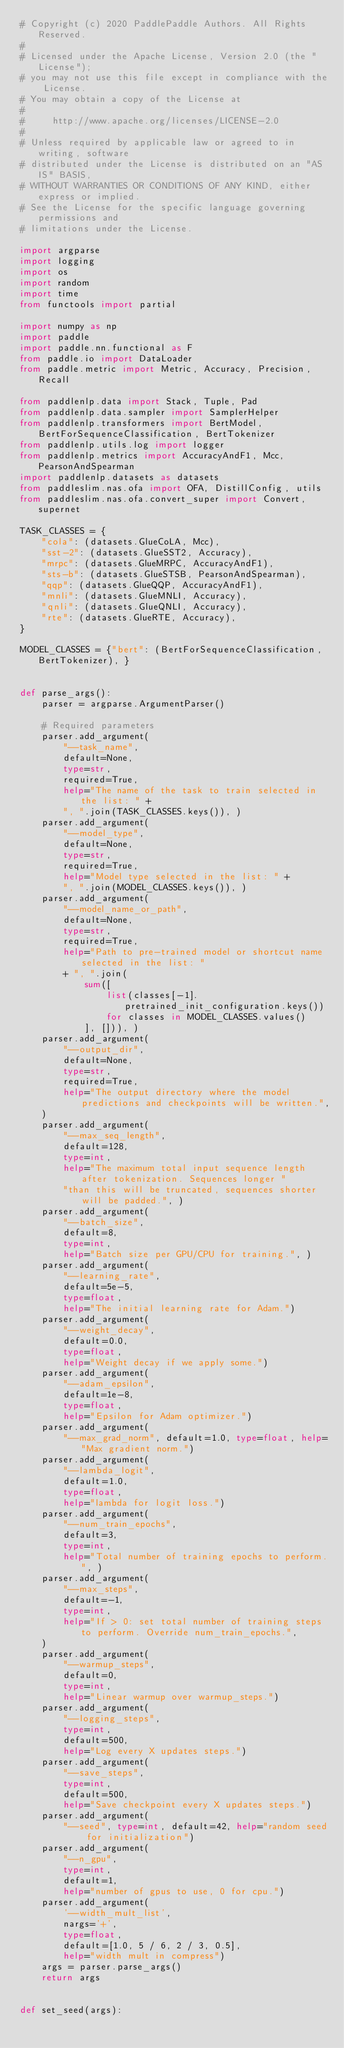<code> <loc_0><loc_0><loc_500><loc_500><_Python_># Copyright (c) 2020 PaddlePaddle Authors. All Rights Reserved.
#
# Licensed under the Apache License, Version 2.0 (the "License");
# you may not use this file except in compliance with the License.
# You may obtain a copy of the License at
#
#     http://www.apache.org/licenses/LICENSE-2.0
#
# Unless required by applicable law or agreed to in writing, software
# distributed under the License is distributed on an "AS IS" BASIS,
# WITHOUT WARRANTIES OR CONDITIONS OF ANY KIND, either express or implied.
# See the License for the specific language governing permissions and
# limitations under the License.

import argparse
import logging
import os
import random
import time
from functools import partial

import numpy as np
import paddle
import paddle.nn.functional as F
from paddle.io import DataLoader
from paddle.metric import Metric, Accuracy, Precision, Recall

from paddlenlp.data import Stack, Tuple, Pad
from paddlenlp.data.sampler import SamplerHelper
from paddlenlp.transformers import BertModel, BertForSequenceClassification, BertTokenizer
from paddlenlp.utils.log import logger
from paddlenlp.metrics import AccuracyAndF1, Mcc, PearsonAndSpearman
import paddlenlp.datasets as datasets
from paddleslim.nas.ofa import OFA, DistillConfig, utils
from paddleslim.nas.ofa.convert_super import Convert, supernet

TASK_CLASSES = {
    "cola": (datasets.GlueCoLA, Mcc),
    "sst-2": (datasets.GlueSST2, Accuracy),
    "mrpc": (datasets.GlueMRPC, AccuracyAndF1),
    "sts-b": (datasets.GlueSTSB, PearsonAndSpearman),
    "qqp": (datasets.GlueQQP, AccuracyAndF1),
    "mnli": (datasets.GlueMNLI, Accuracy),
    "qnli": (datasets.GlueQNLI, Accuracy),
    "rte": (datasets.GlueRTE, Accuracy),
}

MODEL_CLASSES = {"bert": (BertForSequenceClassification, BertTokenizer), }


def parse_args():
    parser = argparse.ArgumentParser()

    # Required parameters
    parser.add_argument(
        "--task_name",
        default=None,
        type=str,
        required=True,
        help="The name of the task to train selected in the list: " +
        ", ".join(TASK_CLASSES.keys()), )
    parser.add_argument(
        "--model_type",
        default=None,
        type=str,
        required=True,
        help="Model type selected in the list: " +
        ", ".join(MODEL_CLASSES.keys()), )
    parser.add_argument(
        "--model_name_or_path",
        default=None,
        type=str,
        required=True,
        help="Path to pre-trained model or shortcut name selected in the list: "
        + ", ".join(
            sum([
                list(classes[-1].pretrained_init_configuration.keys())
                for classes in MODEL_CLASSES.values()
            ], [])), )
    parser.add_argument(
        "--output_dir",
        default=None,
        type=str,
        required=True,
        help="The output directory where the model predictions and checkpoints will be written.",
    )
    parser.add_argument(
        "--max_seq_length",
        default=128,
        type=int,
        help="The maximum total input sequence length after tokenization. Sequences longer "
        "than this will be truncated, sequences shorter will be padded.", )
    parser.add_argument(
        "--batch_size",
        default=8,
        type=int,
        help="Batch size per GPU/CPU for training.", )
    parser.add_argument(
        "--learning_rate",
        default=5e-5,
        type=float,
        help="The initial learning rate for Adam.")
    parser.add_argument(
        "--weight_decay",
        default=0.0,
        type=float,
        help="Weight decay if we apply some.")
    parser.add_argument(
        "--adam_epsilon",
        default=1e-8,
        type=float,
        help="Epsilon for Adam optimizer.")
    parser.add_argument(
        "--max_grad_norm", default=1.0, type=float, help="Max gradient norm.")
    parser.add_argument(
        "--lambda_logit",
        default=1.0,
        type=float,
        help="lambda for logit loss.")
    parser.add_argument(
        "--num_train_epochs",
        default=3,
        type=int,
        help="Total number of training epochs to perform.", )
    parser.add_argument(
        "--max_steps",
        default=-1,
        type=int,
        help="If > 0: set total number of training steps to perform. Override num_train_epochs.",
    )
    parser.add_argument(
        "--warmup_steps",
        default=0,
        type=int,
        help="Linear warmup over warmup_steps.")
    parser.add_argument(
        "--logging_steps",
        type=int,
        default=500,
        help="Log every X updates steps.")
    parser.add_argument(
        "--save_steps",
        type=int,
        default=500,
        help="Save checkpoint every X updates steps.")
    parser.add_argument(
        "--seed", type=int, default=42, help="random seed for initialization")
    parser.add_argument(
        "--n_gpu",
        type=int,
        default=1,
        help="number of gpus to use, 0 for cpu.")
    parser.add_argument(
        '--width_mult_list',
        nargs='+',
        type=float,
        default=[1.0, 5 / 6, 2 / 3, 0.5],
        help="width mult in compress")
    args = parser.parse_args()
    return args


def set_seed(args):</code> 